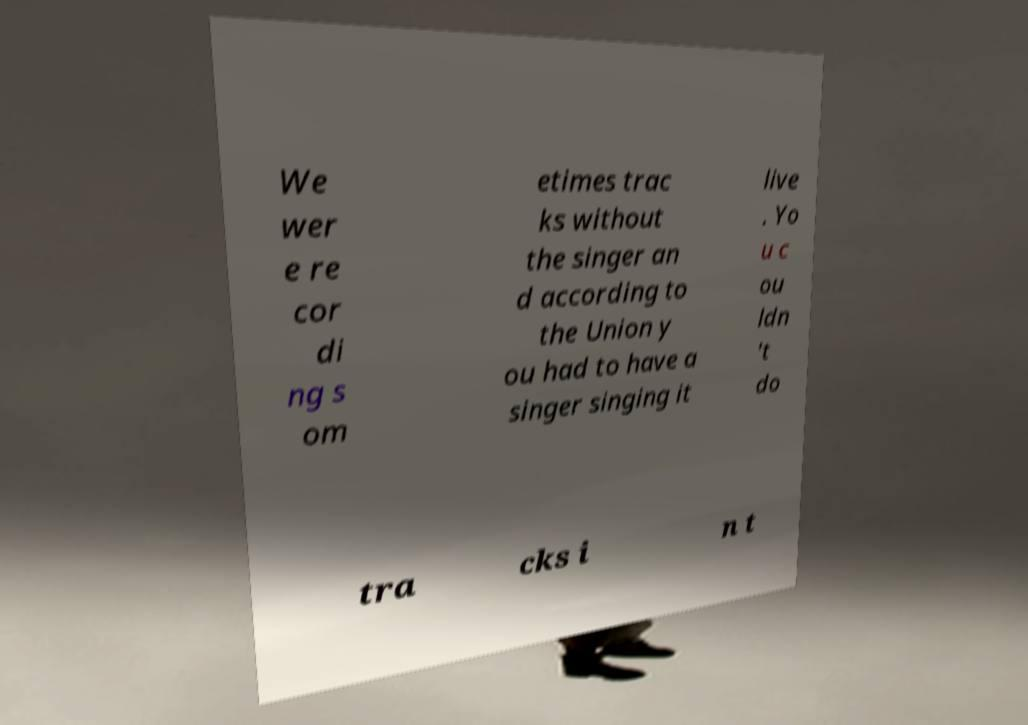For documentation purposes, I need the text within this image transcribed. Could you provide that? We wer e re cor di ng s om etimes trac ks without the singer an d according to the Union y ou had to have a singer singing it live . Yo u c ou ldn 't do tra cks i n t 